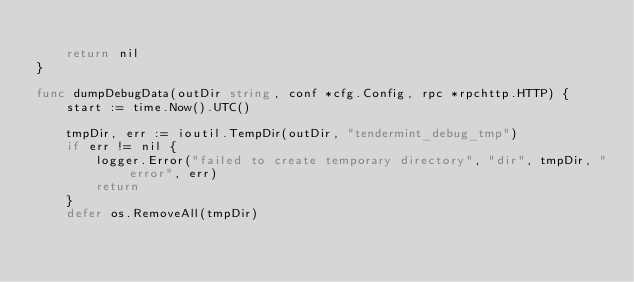Convert code to text. <code><loc_0><loc_0><loc_500><loc_500><_Go_>
	return nil
}

func dumpDebugData(outDir string, conf *cfg.Config, rpc *rpchttp.HTTP) {
	start := time.Now().UTC()

	tmpDir, err := ioutil.TempDir(outDir, "tendermint_debug_tmp")
	if err != nil {
		logger.Error("failed to create temporary directory", "dir", tmpDir, "error", err)
		return
	}
	defer os.RemoveAll(tmpDir)
</code> 